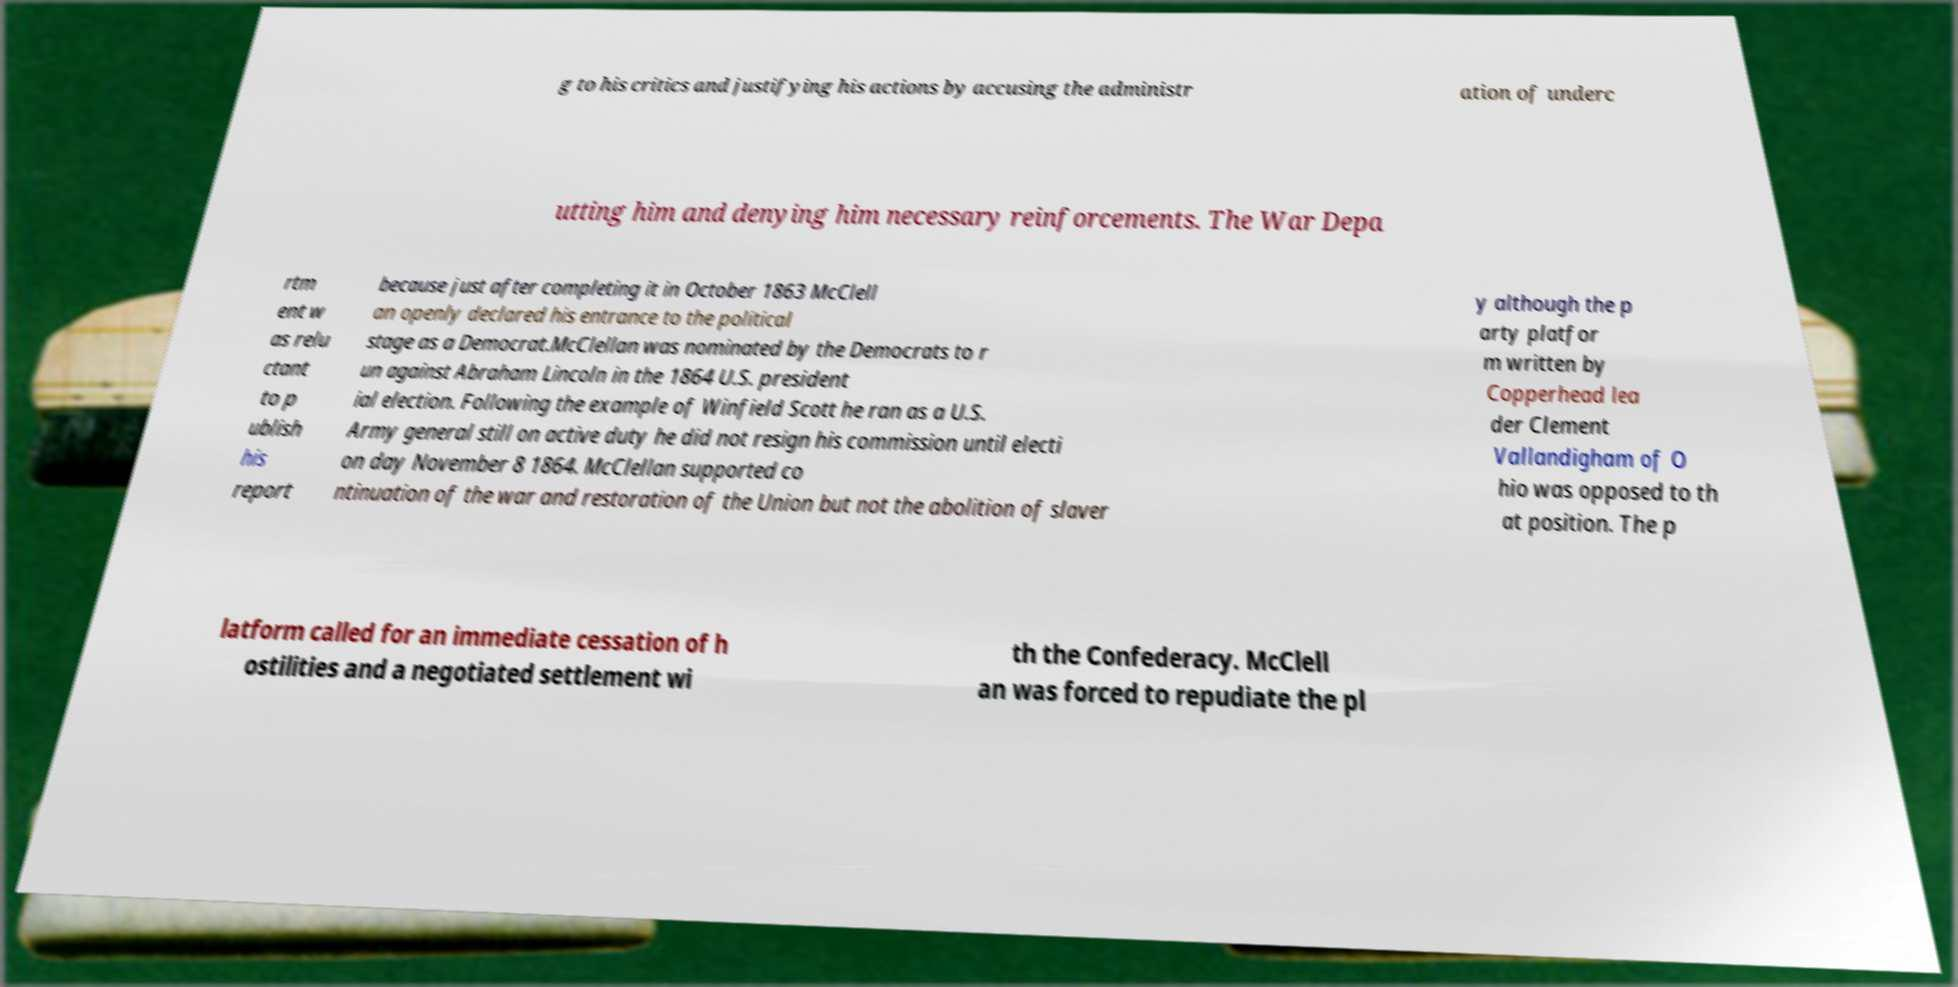Please read and relay the text visible in this image. What does it say? g to his critics and justifying his actions by accusing the administr ation of underc utting him and denying him necessary reinforcements. The War Depa rtm ent w as relu ctant to p ublish his report because just after completing it in October 1863 McClell an openly declared his entrance to the political stage as a Democrat.McClellan was nominated by the Democrats to r un against Abraham Lincoln in the 1864 U.S. president ial election. Following the example of Winfield Scott he ran as a U.S. Army general still on active duty he did not resign his commission until electi on day November 8 1864. McClellan supported co ntinuation of the war and restoration of the Union but not the abolition of slaver y although the p arty platfor m written by Copperhead lea der Clement Vallandigham of O hio was opposed to th at position. The p latform called for an immediate cessation of h ostilities and a negotiated settlement wi th the Confederacy. McClell an was forced to repudiate the pl 